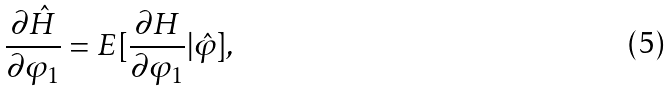<formula> <loc_0><loc_0><loc_500><loc_500>\frac { \partial \hat { H } } { \partial \varphi _ { 1 } } = E [ \frac { \partial H } { \partial \varphi _ { 1 } } | \hat { \varphi } ] ,</formula> 